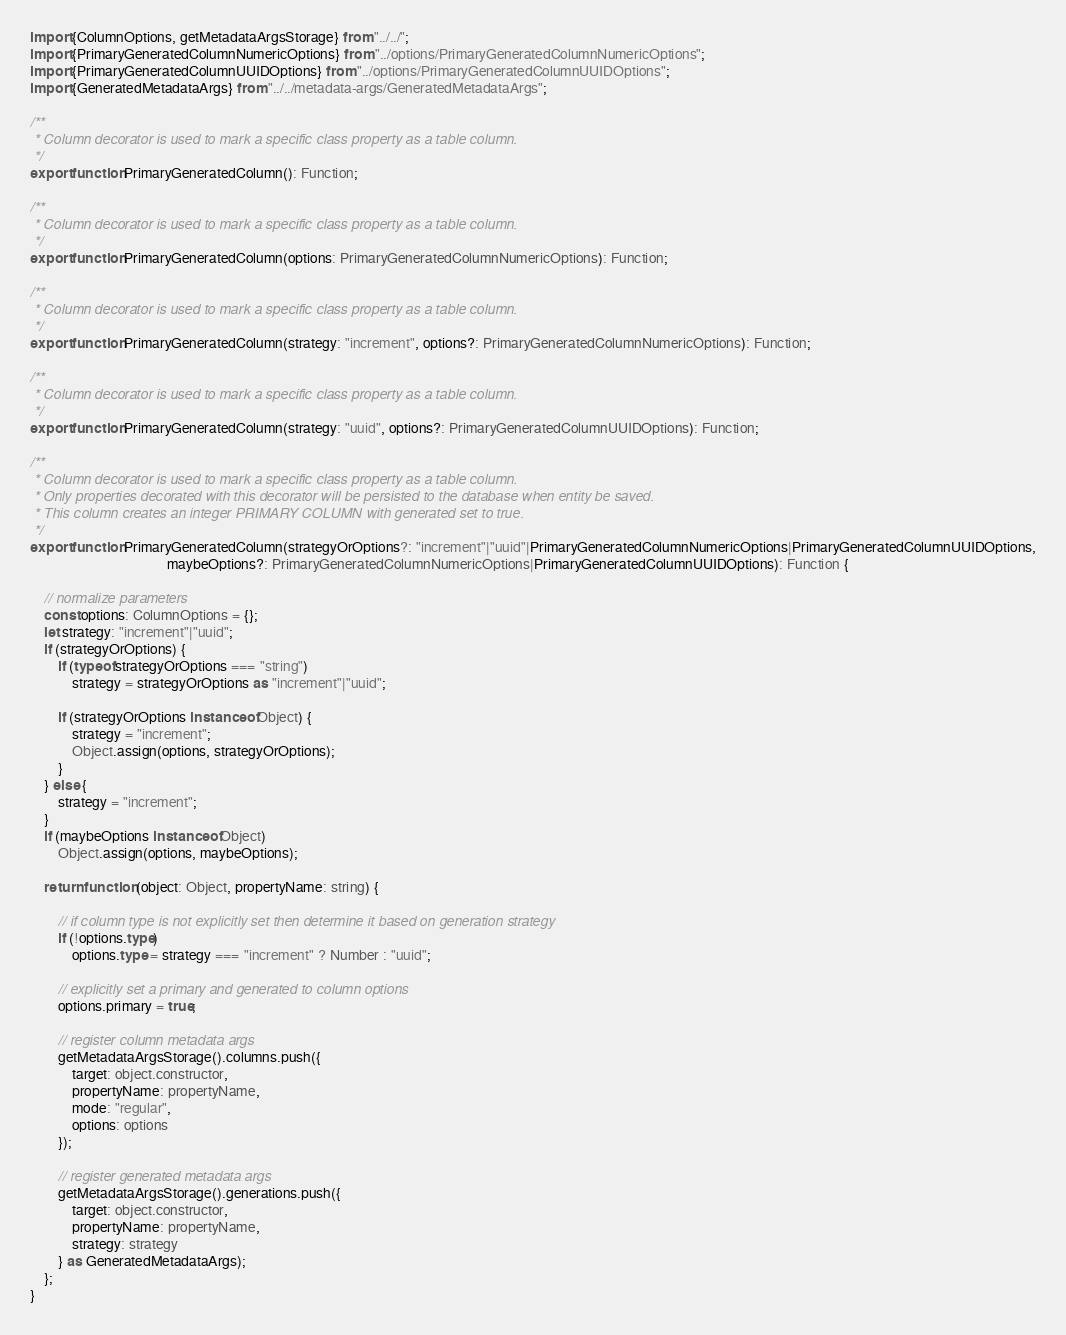<code> <loc_0><loc_0><loc_500><loc_500><_TypeScript_>import {ColumnOptions, getMetadataArgsStorage} from "../../";
import {PrimaryGeneratedColumnNumericOptions} from "../options/PrimaryGeneratedColumnNumericOptions";
import {PrimaryGeneratedColumnUUIDOptions} from "../options/PrimaryGeneratedColumnUUIDOptions";
import {GeneratedMetadataArgs} from "../../metadata-args/GeneratedMetadataArgs";

/**
 * Column decorator is used to mark a specific class property as a table column.
 */
export function PrimaryGeneratedColumn(): Function;

/**
 * Column decorator is used to mark a specific class property as a table column.
 */
export function PrimaryGeneratedColumn(options: PrimaryGeneratedColumnNumericOptions): Function;

/**
 * Column decorator is used to mark a specific class property as a table column.
 */
export function PrimaryGeneratedColumn(strategy: "increment", options?: PrimaryGeneratedColumnNumericOptions): Function;

/**
 * Column decorator is used to mark a specific class property as a table column.
 */
export function PrimaryGeneratedColumn(strategy: "uuid", options?: PrimaryGeneratedColumnUUIDOptions): Function;

/**
 * Column decorator is used to mark a specific class property as a table column.
 * Only properties decorated with this decorator will be persisted to the database when entity be saved.
 * This column creates an integer PRIMARY COLUMN with generated set to true.
 */
export function PrimaryGeneratedColumn(strategyOrOptions?: "increment"|"uuid"|PrimaryGeneratedColumnNumericOptions|PrimaryGeneratedColumnUUIDOptions,
                                       maybeOptions?: PrimaryGeneratedColumnNumericOptions|PrimaryGeneratedColumnUUIDOptions): Function {

    // normalize parameters
    const options: ColumnOptions = {};
    let strategy: "increment"|"uuid";
    if (strategyOrOptions) {
        if (typeof strategyOrOptions === "string")
            strategy = strategyOrOptions as "increment"|"uuid";

        if (strategyOrOptions instanceof Object) {
            strategy = "increment";
            Object.assign(options, strategyOrOptions);
        }
    } else {
        strategy = "increment";
    }
    if (maybeOptions instanceof Object)
        Object.assign(options, maybeOptions);

    return function (object: Object, propertyName: string) {

        // if column type is not explicitly set then determine it based on generation strategy
        if (!options.type)
            options.type = strategy === "increment" ? Number : "uuid";

        // explicitly set a primary and generated to column options
        options.primary = true;

        // register column metadata args
        getMetadataArgsStorage().columns.push({
            target: object.constructor,
            propertyName: propertyName,
            mode: "regular",
            options: options
        });

        // register generated metadata args
        getMetadataArgsStorage().generations.push({
            target: object.constructor,
            propertyName: propertyName,
            strategy: strategy
        } as GeneratedMetadataArgs);
    };
}
</code> 